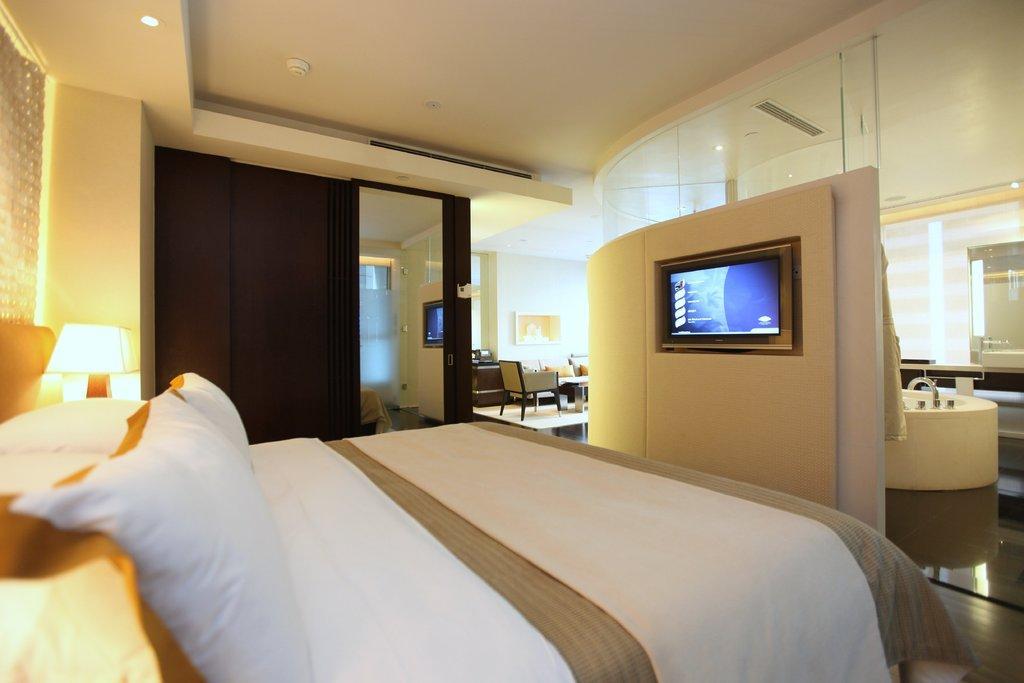Could you give a brief overview of what you see in this image? In the picture I can see the bed on the floor and I can see the pillows and blankets on the bed. There is a table lamp on the left side. I can see a television on the wall on the right side. It is looking like a wash basin and there is a water tap. I can see the mirror on the right side. There is a lamp on the roof on the top left side. It is looking like a wooden cabinet on the left side. I can see the table and a chair on the floor. 